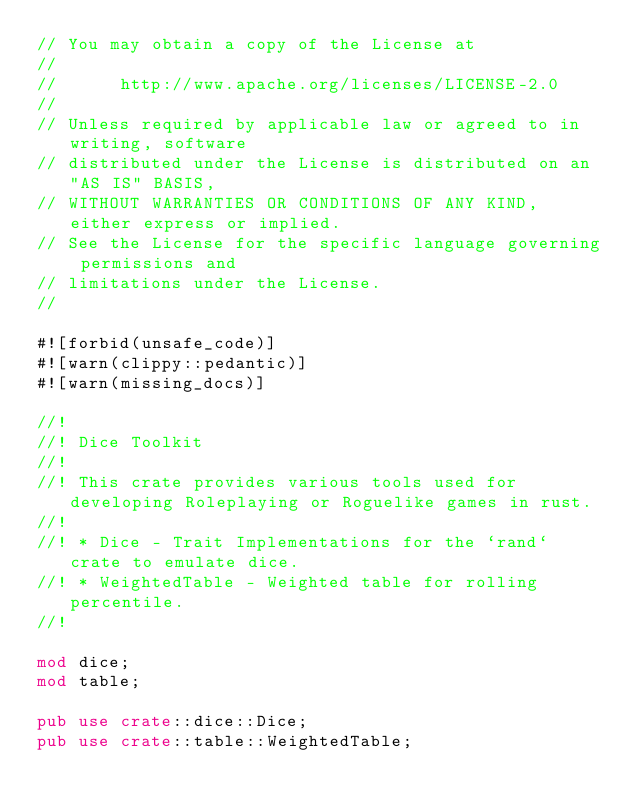Convert code to text. <code><loc_0><loc_0><loc_500><loc_500><_Rust_>// You may obtain a copy of the License at
//
//      http://www.apache.org/licenses/LICENSE-2.0
//
// Unless required by applicable law or agreed to in writing, software
// distributed under the License is distributed on an "AS IS" BASIS,
// WITHOUT WARRANTIES OR CONDITIONS OF ANY KIND, either express or implied.
// See the License for the specific language governing permissions and
// limitations under the License.
//

#![forbid(unsafe_code)]
#![warn(clippy::pedantic)]
#![warn(missing_docs)]

//!
//! Dice Toolkit
//!
//! This crate provides various tools used for developing Roleplaying or Roguelike games in rust.
//!
//! * Dice - Trait Implementations for the `rand` crate to emulate dice.
//! * WeightedTable - Weighted table for rolling percentile.
//!

mod dice;
mod table;

pub use crate::dice::Dice;
pub use crate::table::WeightedTable;
</code> 